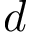<formula> <loc_0><loc_0><loc_500><loc_500>d</formula> 